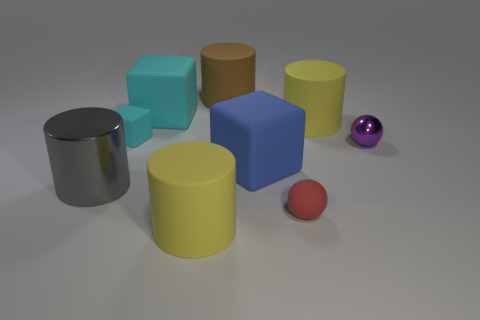Subtract all cyan matte blocks. How many blocks are left? 1 Subtract all cyan blocks. How many blocks are left? 1 Subtract all brown cylinders. How many cyan cubes are left? 2 Subtract 2 blocks. How many blocks are left? 1 Subtract 0 green balls. How many objects are left? 9 Subtract all balls. How many objects are left? 7 Subtract all red balls. Subtract all yellow cylinders. How many balls are left? 1 Subtract all yellow matte balls. Subtract all red rubber balls. How many objects are left? 8 Add 1 big blocks. How many big blocks are left? 3 Add 1 red matte cylinders. How many red matte cylinders exist? 1 